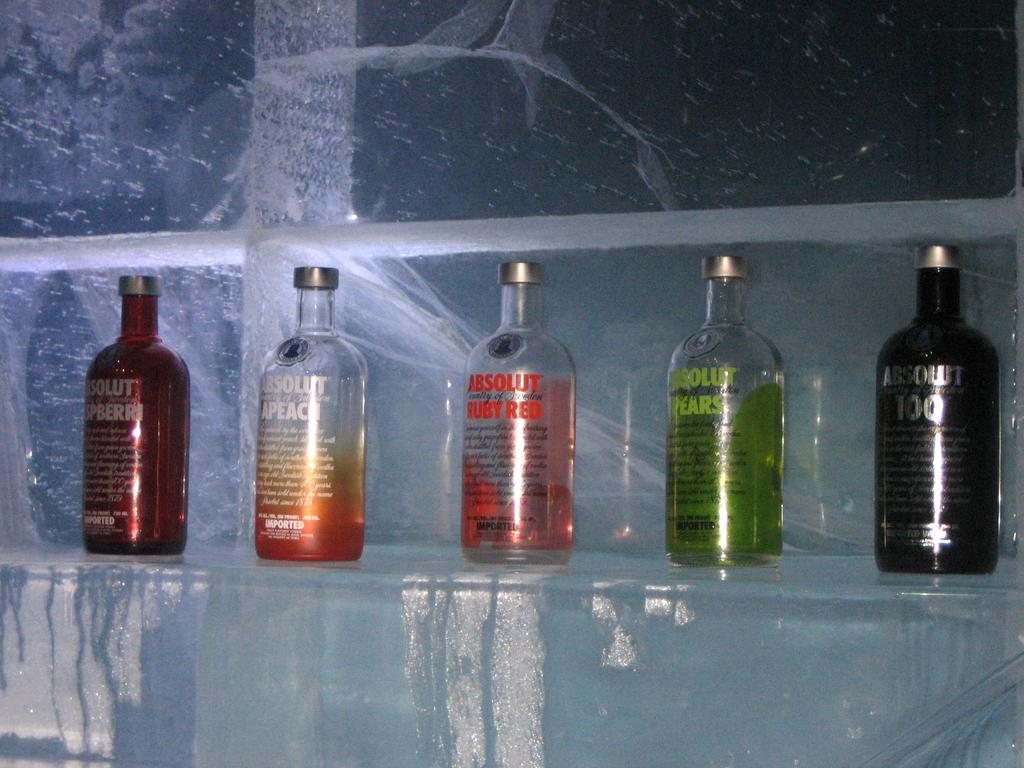<image>
Share a concise interpretation of the image provided. Several different flavors of Absolut Vodka are on a shelf made of ice. 